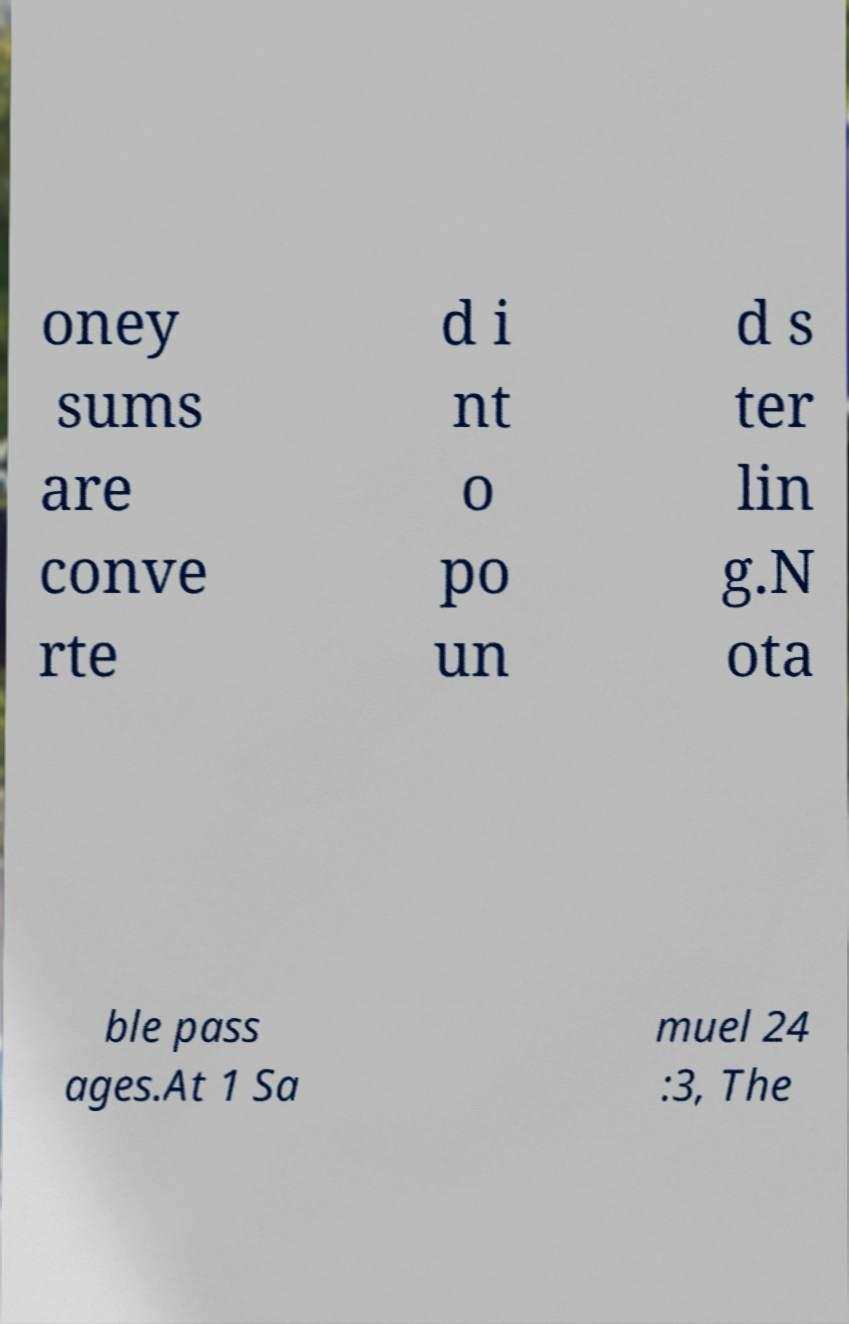There's text embedded in this image that I need extracted. Can you transcribe it verbatim? oney sums are conve rte d i nt o po un d s ter lin g.N ota ble pass ages.At 1 Sa muel 24 :3, The 